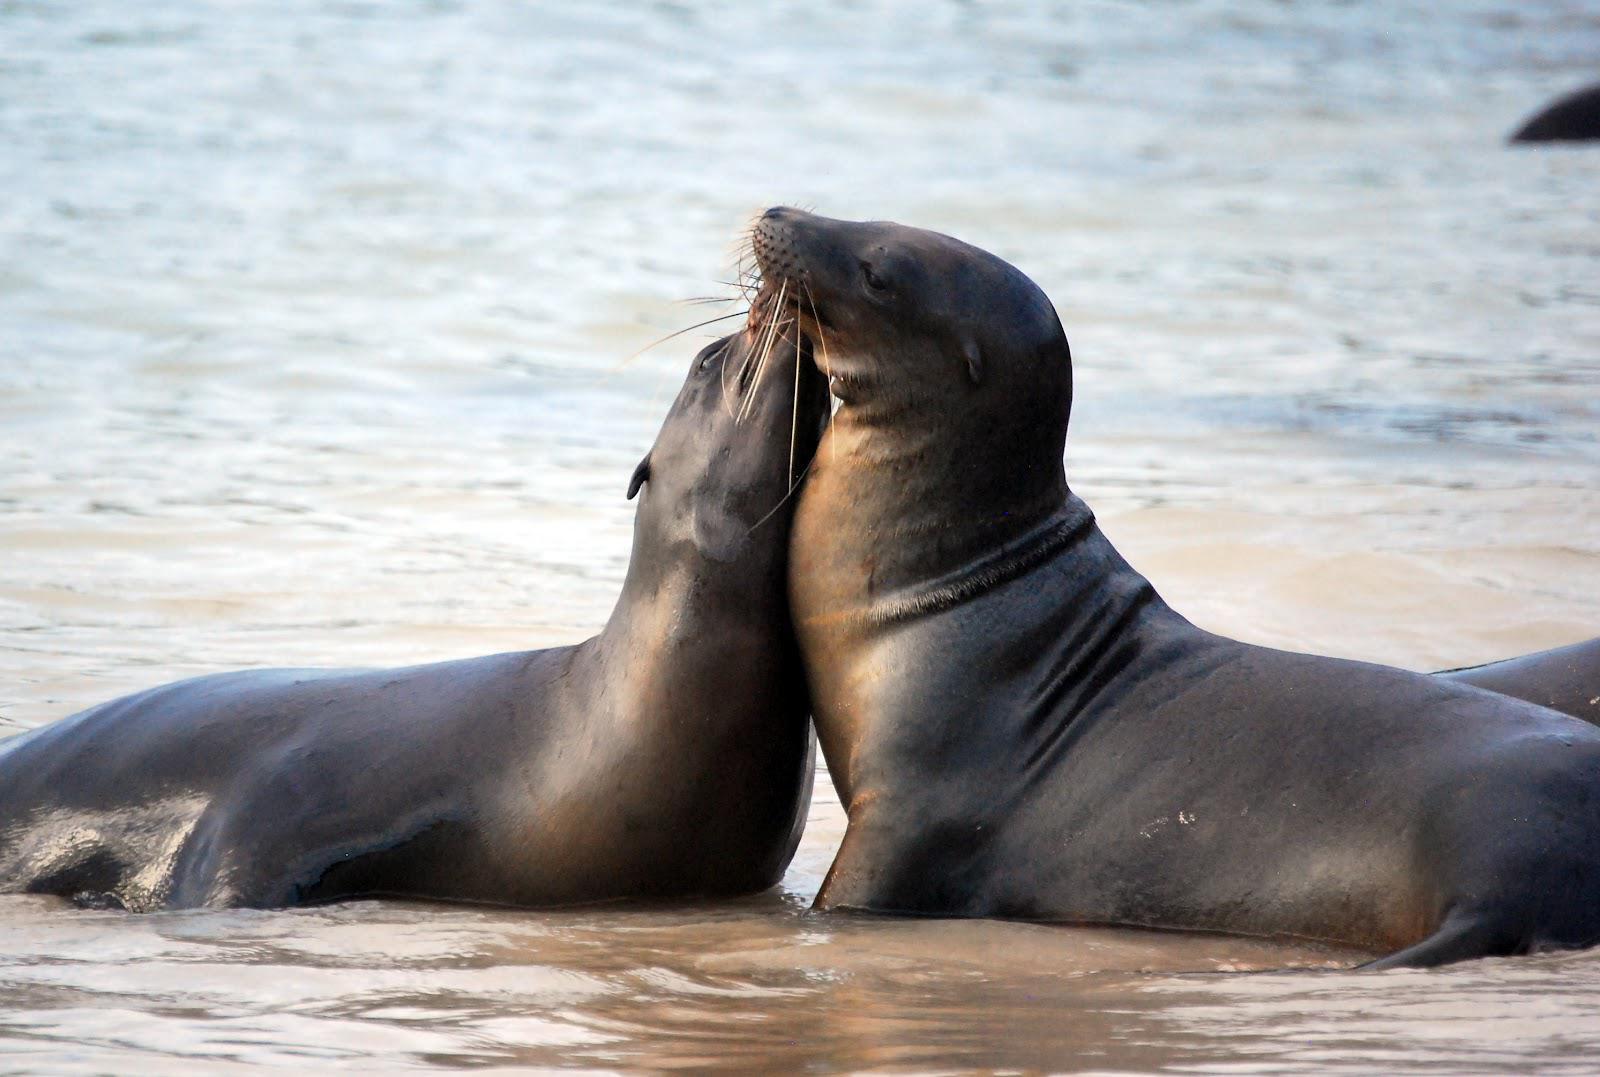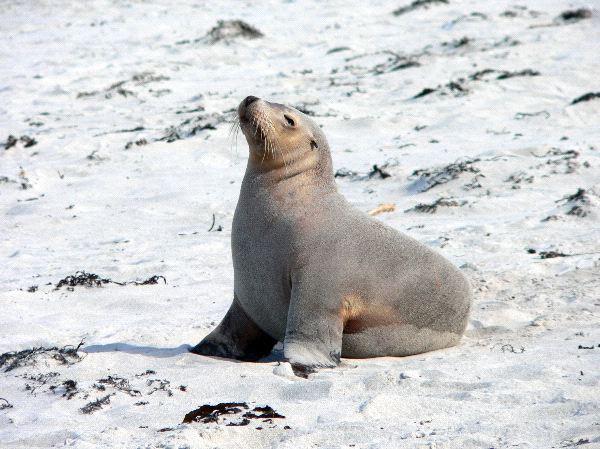The first image is the image on the left, the second image is the image on the right. Considering the images on both sides, is "The left image contains no more than one seal." valid? Answer yes or no. No. The first image is the image on the left, the second image is the image on the right. Analyze the images presented: Is the assertion "A single seal is on the beach in the image on the left." valid? Answer yes or no. No. 